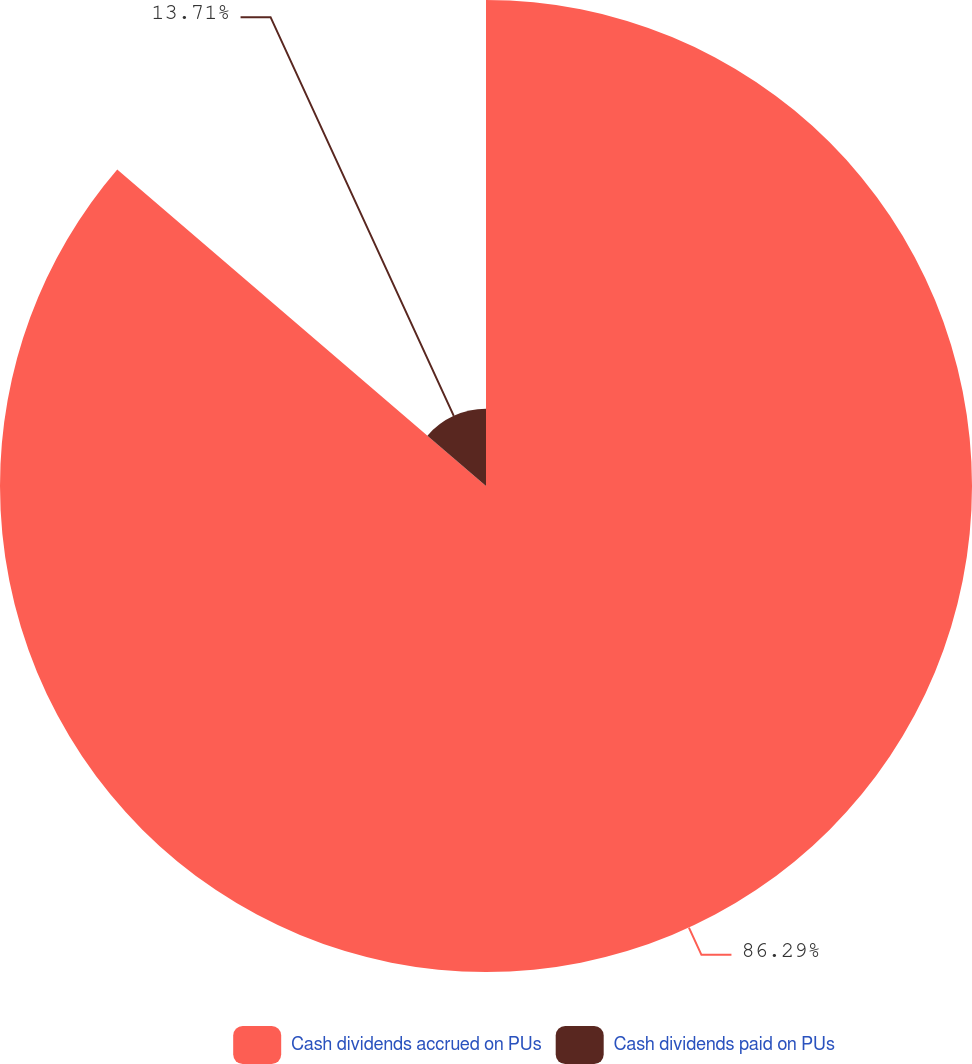Convert chart. <chart><loc_0><loc_0><loc_500><loc_500><pie_chart><fcel>Cash dividends accrued on PUs<fcel>Cash dividends paid on PUs<nl><fcel>86.29%<fcel>13.71%<nl></chart> 